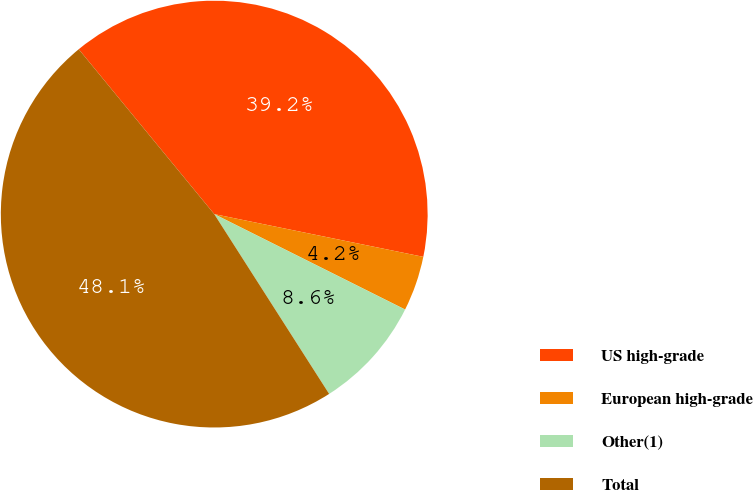Convert chart. <chart><loc_0><loc_0><loc_500><loc_500><pie_chart><fcel>US high-grade<fcel>European high-grade<fcel>Other(1)<fcel>Total<nl><fcel>39.16%<fcel>4.17%<fcel>8.57%<fcel>48.1%<nl></chart> 